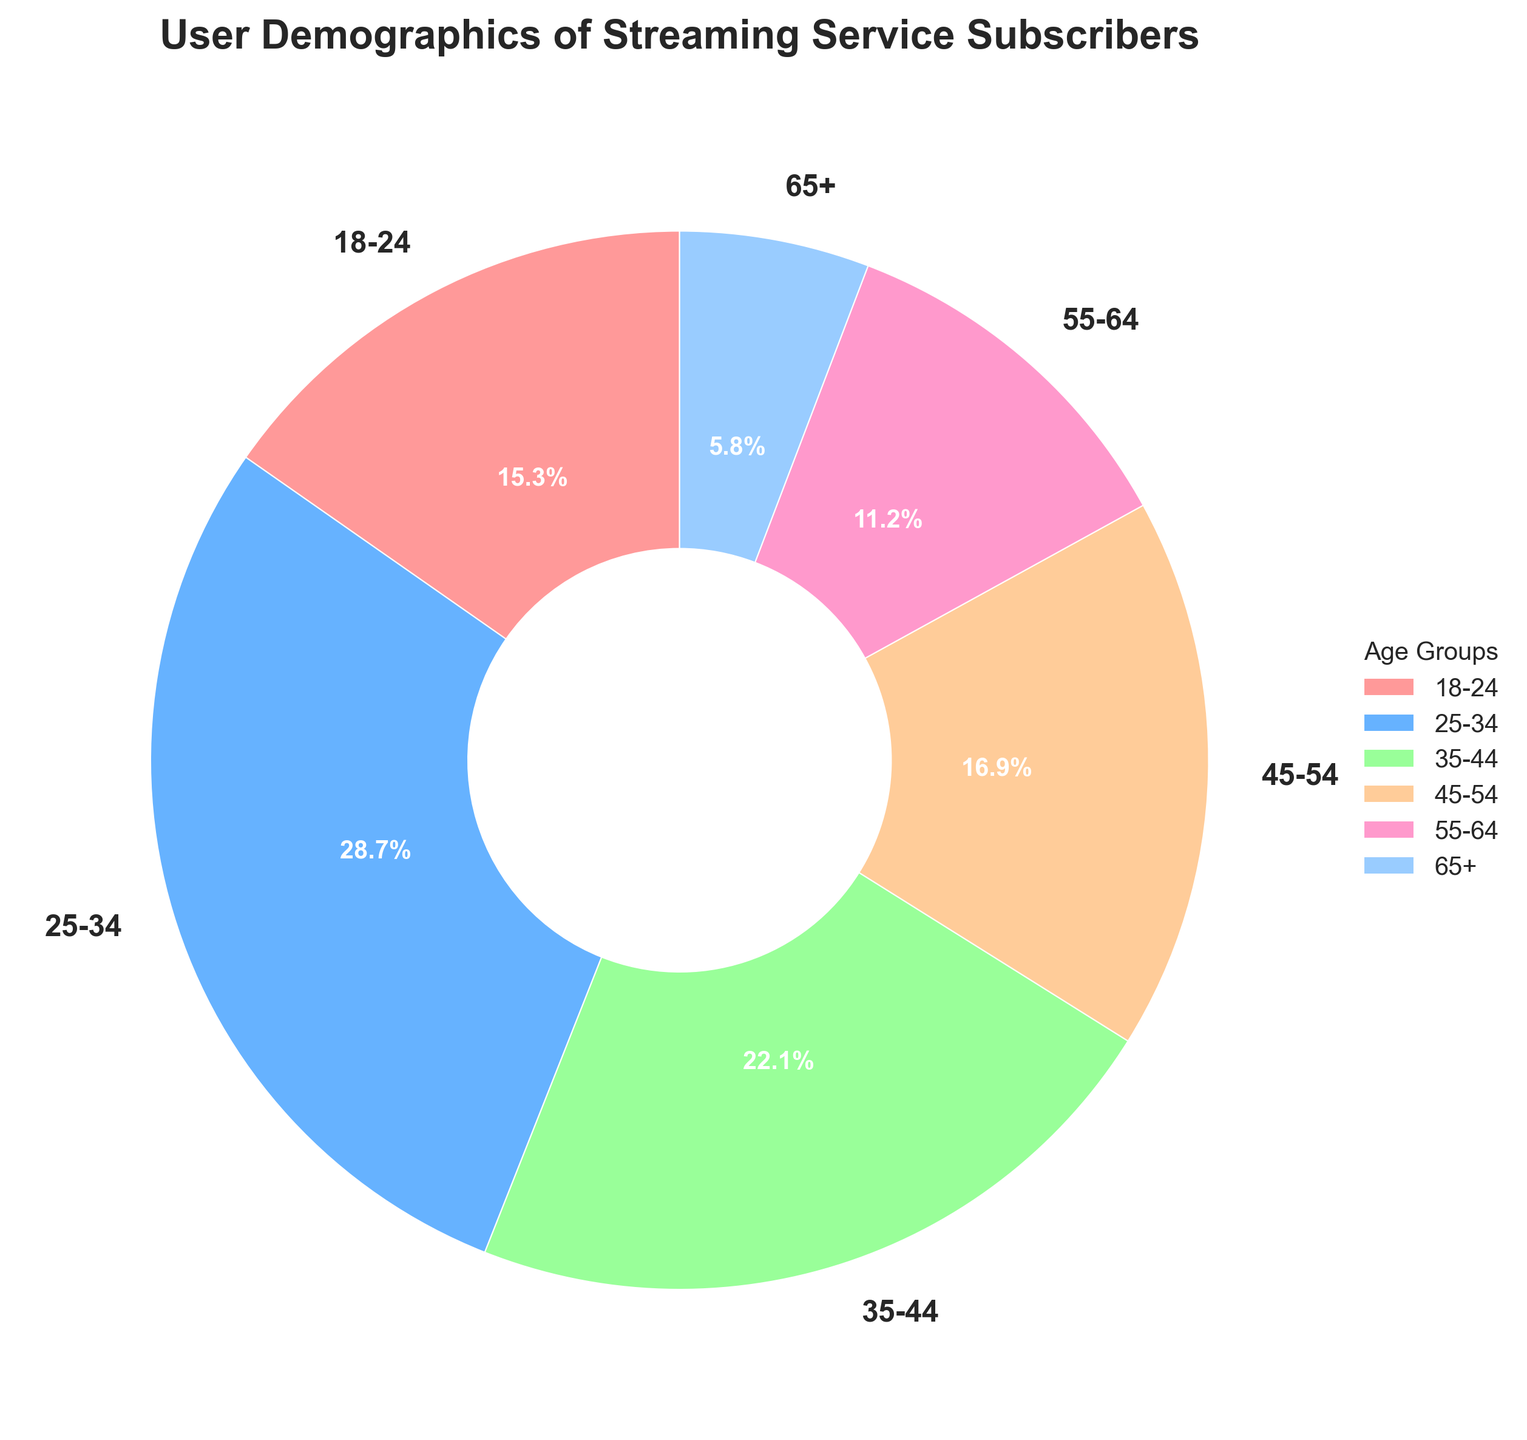What percentage of subscribers are aged between 18-34? The age groups 18-24 and 25-34 fall between 18-34. Add their percentages: 15.3% + 28.7% = 44%
Answer: 44% Which age group forms the largest proportion of subscribers? From the pie chart, identify which age group has the highest percentage. The 25-34 age group has the highest percentage at 28.7%.
Answer: 25-34 What is the difference in percentage between the 25-34 and 65+ age groups? From the pie chart, the percentage for 25-34 is 28.7% and for 65+ is 5.8%. Subtract the smaller from the larger: 28.7% - 5.8% = 22.9%
Answer: 22.9% Which age group is depicted in light blue? Visually inspect the pie chart and identify the segment with a light blue color. The 35-44 age group is light blue.
Answer: 35-44 What is the combined percentage of subscribers aged 55 and above? Ages 55-64 and 65+ are above 55. Add their percentages: 11.2% + 5.8% = 17%
Answer: 17% How does the percentage of subscribers aged 35-44 compare to those aged 45-54? From the pie chart, the percentage for 35-44 is 22.1% and for 45-54 is 16.9%. Compare the two values: 22.1% is greater than 16.9%.
Answer: 35-44 is greater than 45-54 If the total number of subscribers is 1,000, how many subscribers belong to the 18-24 age group? The percentage of subscribers aged 18-24 is 15.3%. Calculate the number using the total: 15.3% of 1,000 is 0.153 * 1,000 = 153 subscribers.
Answer: 153 What is the sum of the percentages of the two smallest age groups? The smallest age groups by percentage are 65+ and 55-64. Add their percentages: 5.8% + 11.2% = 17%
Answer: 17% Which color is used to represent the 55-64 age group? Visually inspect the pie chart and identify the color for the 55-64 age group. The 55-64 age group is depicted in pink.
Answer: Pink 